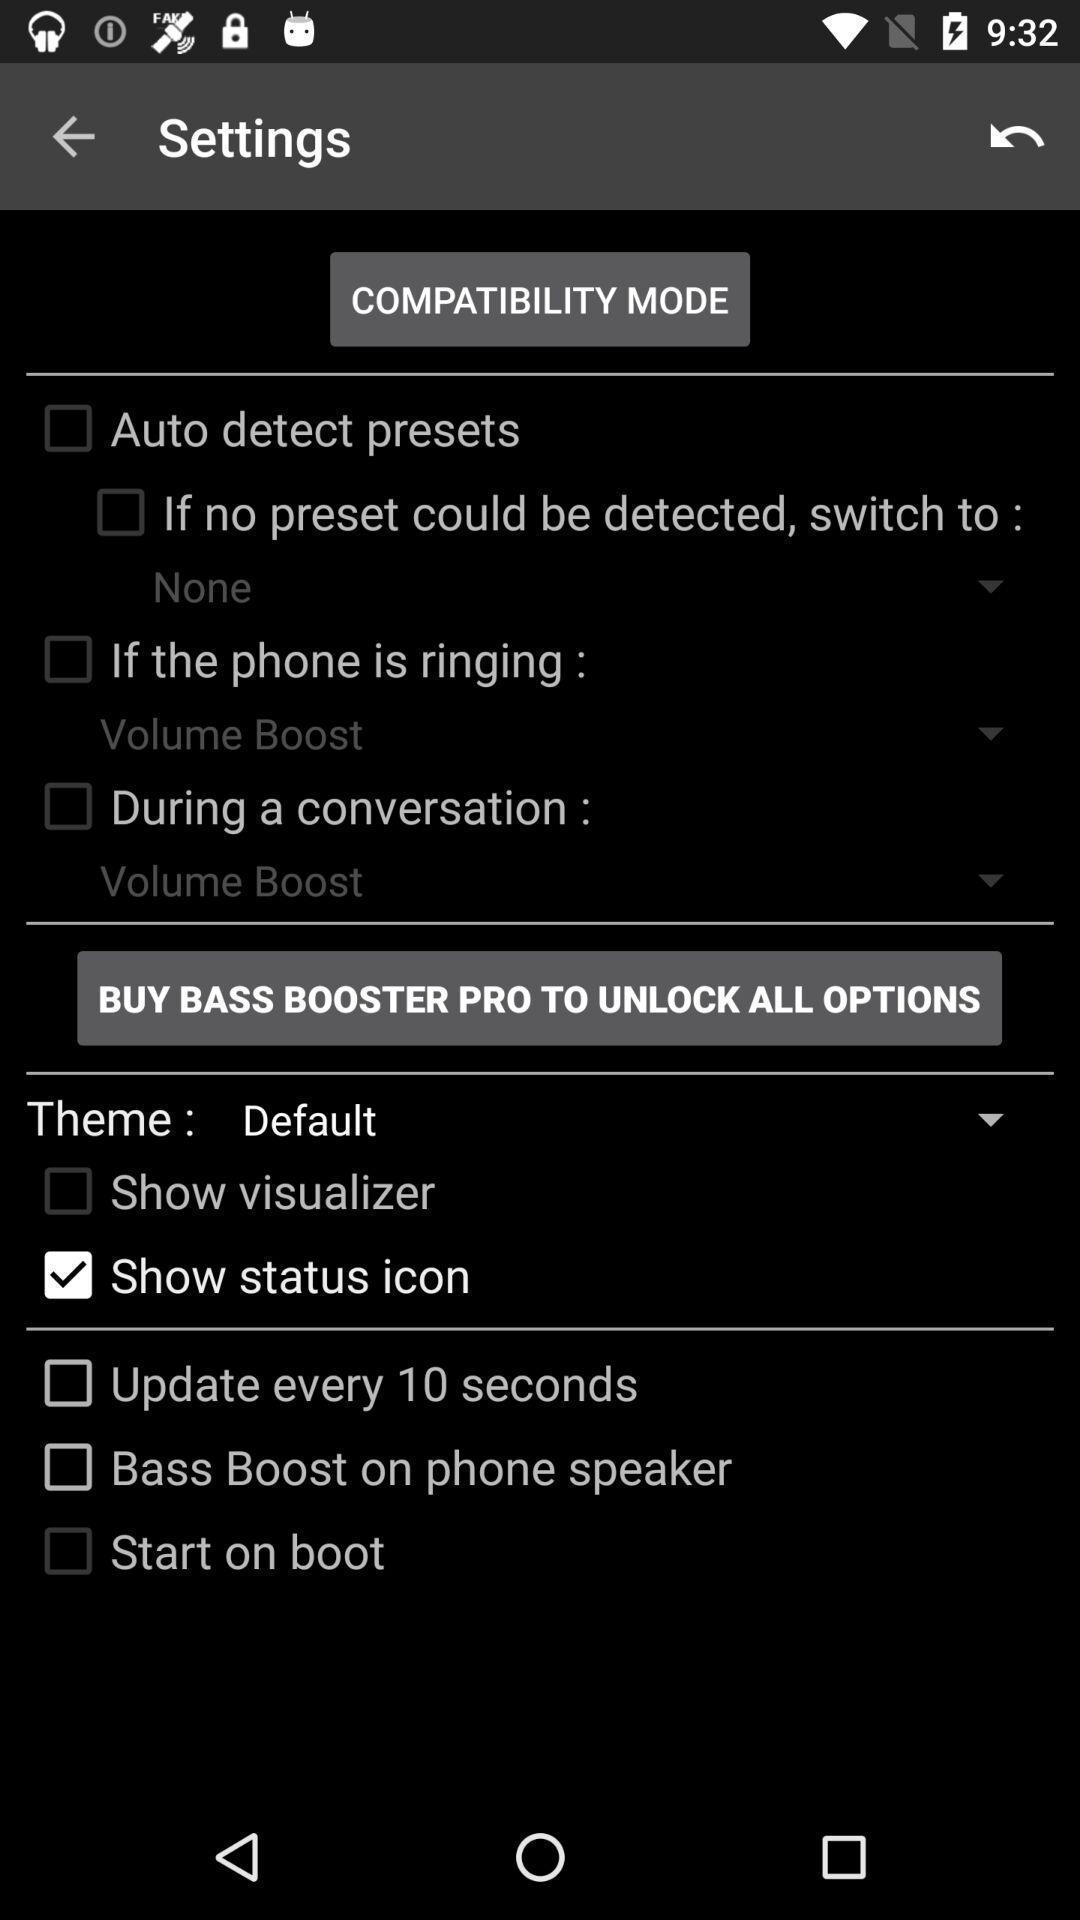Summarize the information in this screenshot. Settings page displaying. 